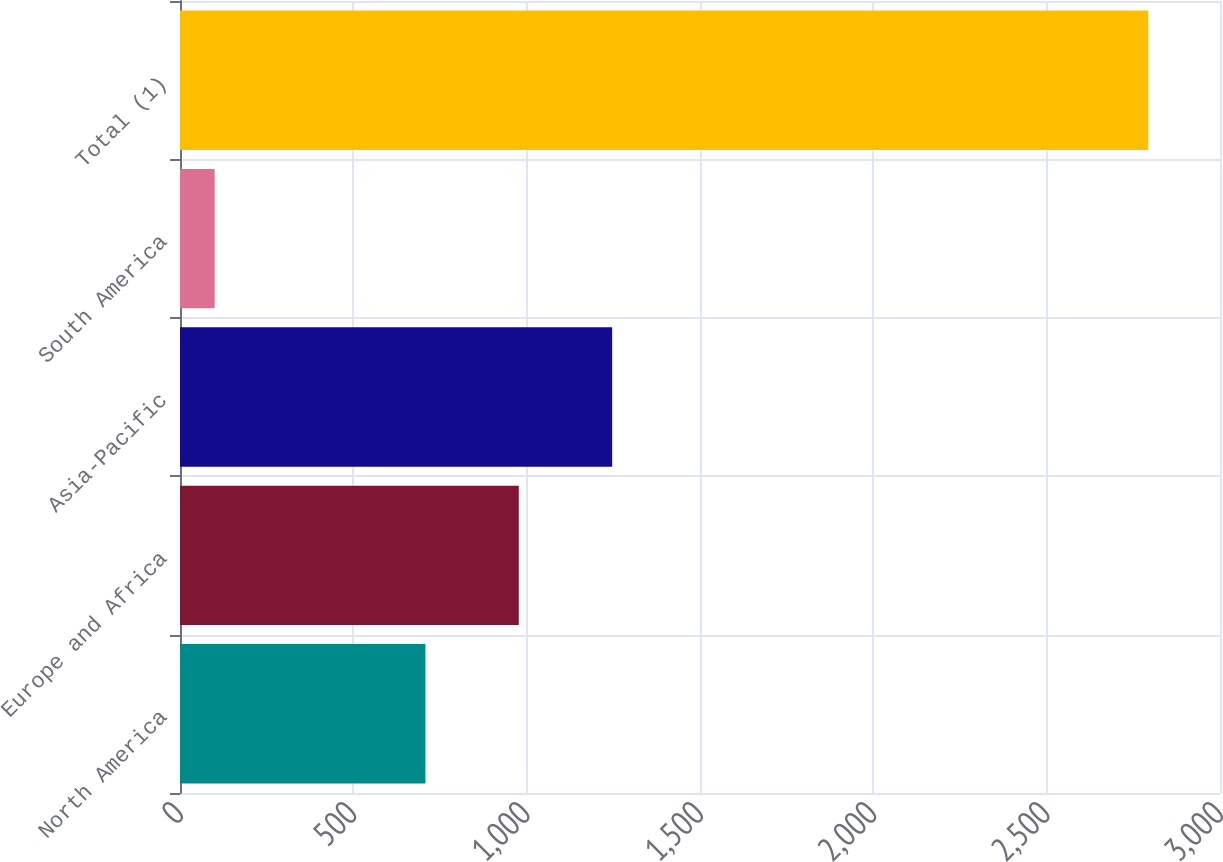<chart> <loc_0><loc_0><loc_500><loc_500><bar_chart><fcel>North America<fcel>Europe and Africa<fcel>Asia-Pacific<fcel>South America<fcel>Total (1)<nl><fcel>708<fcel>977.3<fcel>1246.6<fcel>100<fcel>2793<nl></chart> 